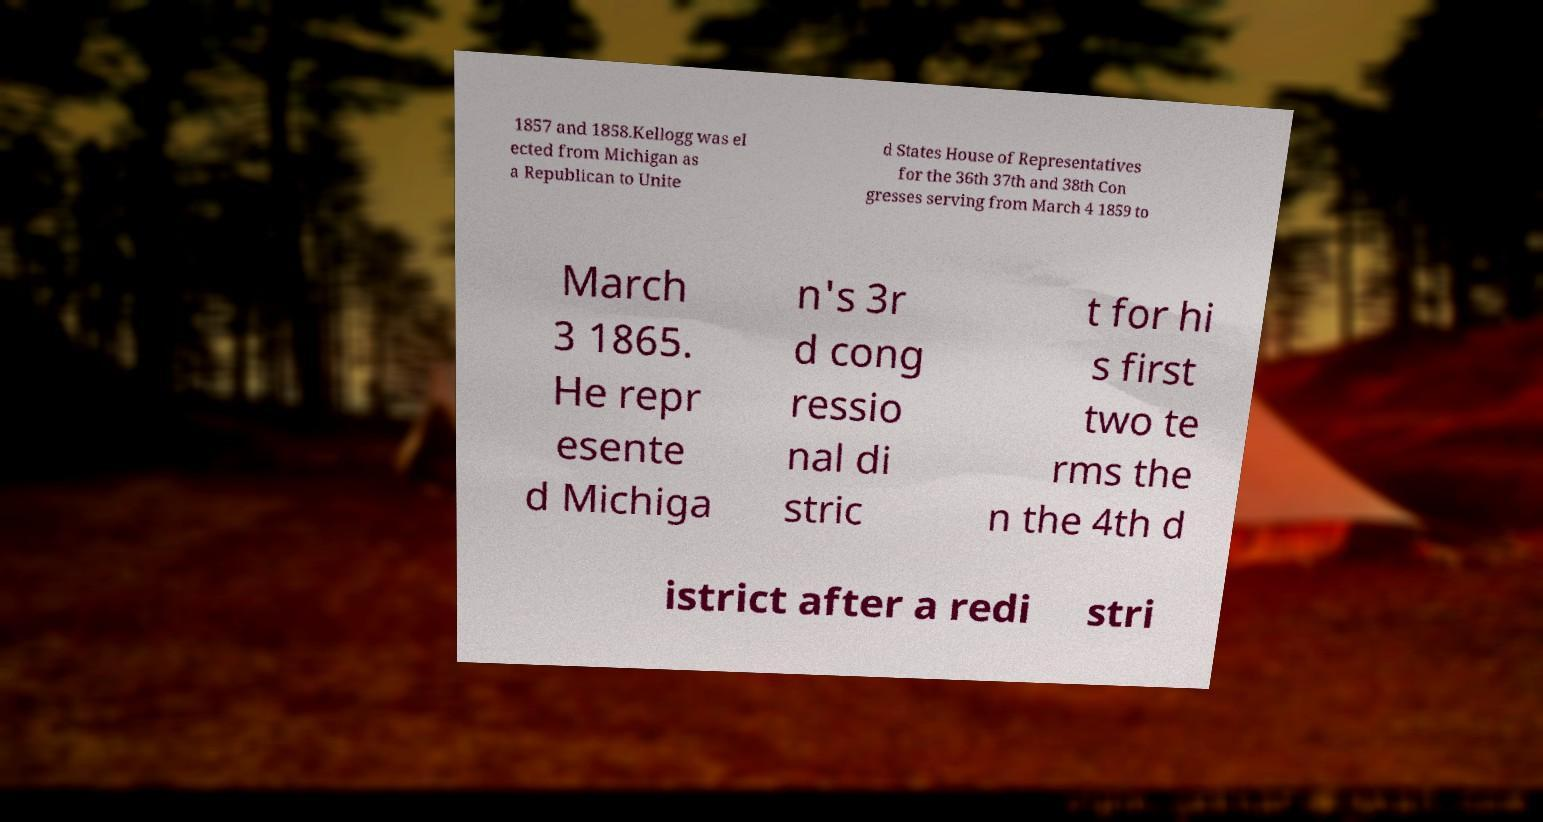For documentation purposes, I need the text within this image transcribed. Could you provide that? 1857 and 1858.Kellogg was el ected from Michigan as a Republican to Unite d States House of Representatives for the 36th 37th and 38th Con gresses serving from March 4 1859 to March 3 1865. He repr esente d Michiga n's 3r d cong ressio nal di stric t for hi s first two te rms the n the 4th d istrict after a redi stri 